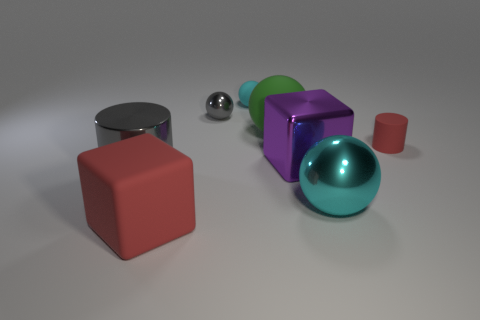Do the metal block and the tiny shiny thing have the same color?
Make the answer very short. No. What material is the other sphere that is the same color as the large shiny sphere?
Make the answer very short. Rubber. How many small rubber things are both on the right side of the small cyan object and behind the small cylinder?
Make the answer very short. 0. What is the shape of the cyan thing that is the same size as the gray ball?
Provide a short and direct response. Sphere. There is a cylinder on the left side of the cyan sphere behind the large gray metallic object; is there a large metal object behind it?
Make the answer very short. Yes. There is a small rubber cylinder; does it have the same color as the large block that is in front of the shiny cylinder?
Ensure brevity in your answer.  Yes. How many tiny matte things are the same color as the big rubber cube?
Your answer should be very brief. 1. How big is the rubber object that is in front of the ball that is in front of the big gray object?
Offer a terse response. Large. What number of things are either large spheres on the left side of the purple cube or small green metallic blocks?
Ensure brevity in your answer.  1. Are there any purple rubber blocks of the same size as the red rubber block?
Provide a succinct answer. No. 